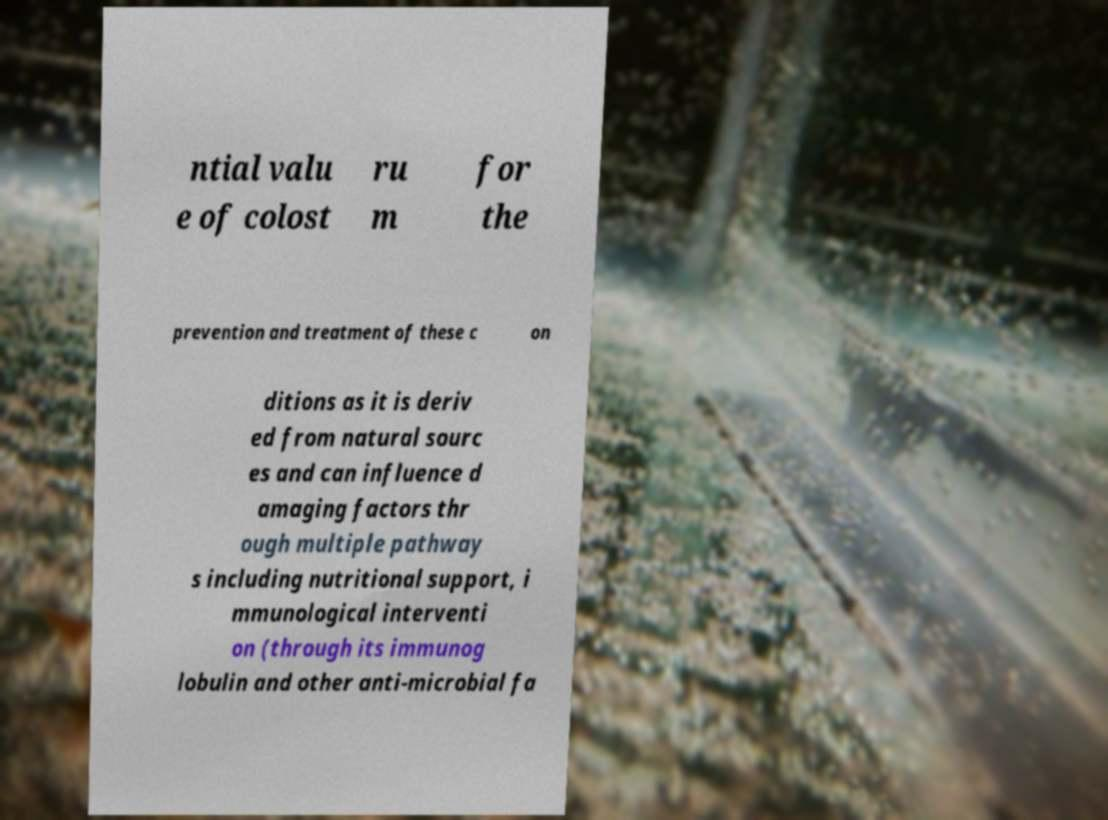There's text embedded in this image that I need extracted. Can you transcribe it verbatim? ntial valu e of colost ru m for the prevention and treatment of these c on ditions as it is deriv ed from natural sourc es and can influence d amaging factors thr ough multiple pathway s including nutritional support, i mmunological interventi on (through its immunog lobulin and other anti-microbial fa 